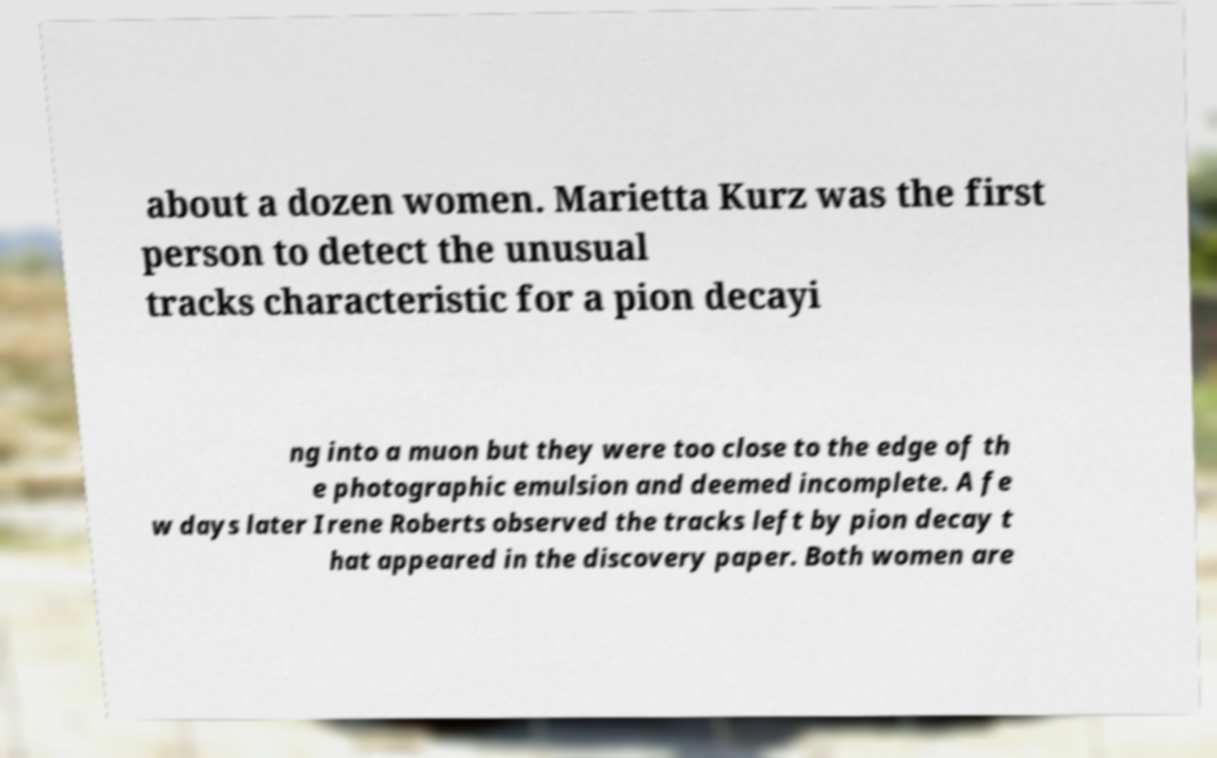Can you read and provide the text displayed in the image?This photo seems to have some interesting text. Can you extract and type it out for me? about a dozen women. Marietta Kurz was the first person to detect the unusual tracks characteristic for a pion decayi ng into a muon but they were too close to the edge of th e photographic emulsion and deemed incomplete. A fe w days later Irene Roberts observed the tracks left by pion decay t hat appeared in the discovery paper. Both women are 